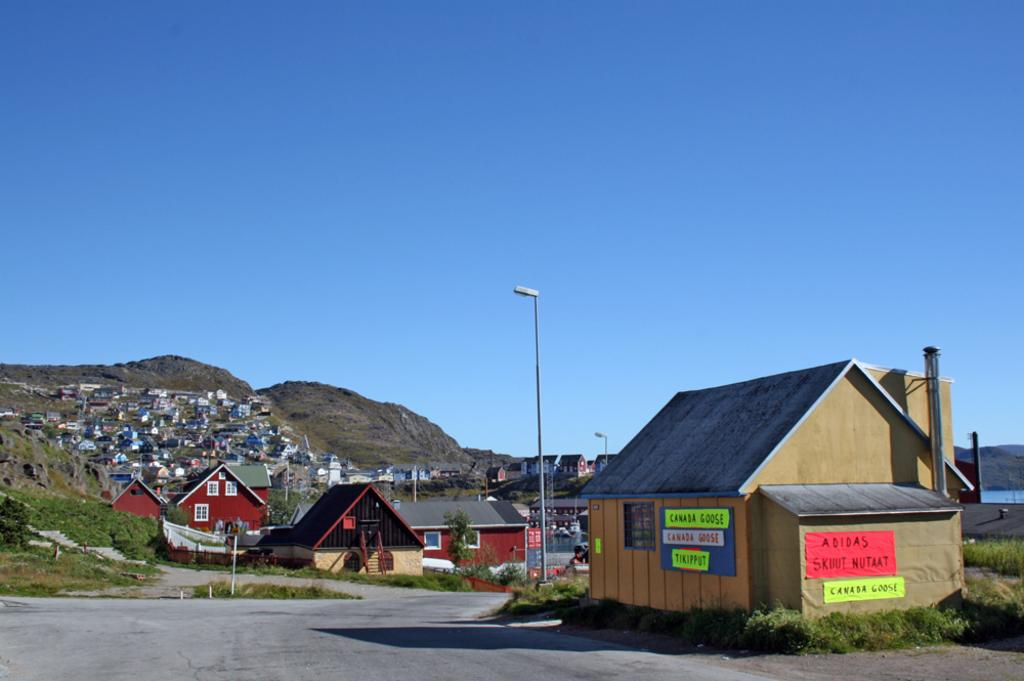What type of structures can be seen in the image? There are houses in the image. What is the tall, vertical object in the image? There is a light pole in the image. What type of natural features are visible in the image? There are mountains, plants, grass, and a lake in the image. What part of the natural environment is visible in the image? The sky is visible in the image. How many trucks are parked near the houses in the image? There is no truck present in the image. What type of coat is draped over the light pole in the image? There is no coat present in the image; only the light pole and other objects mentioned in the facts are visible. 